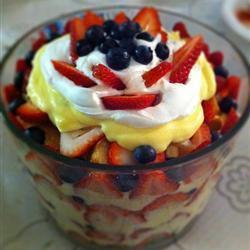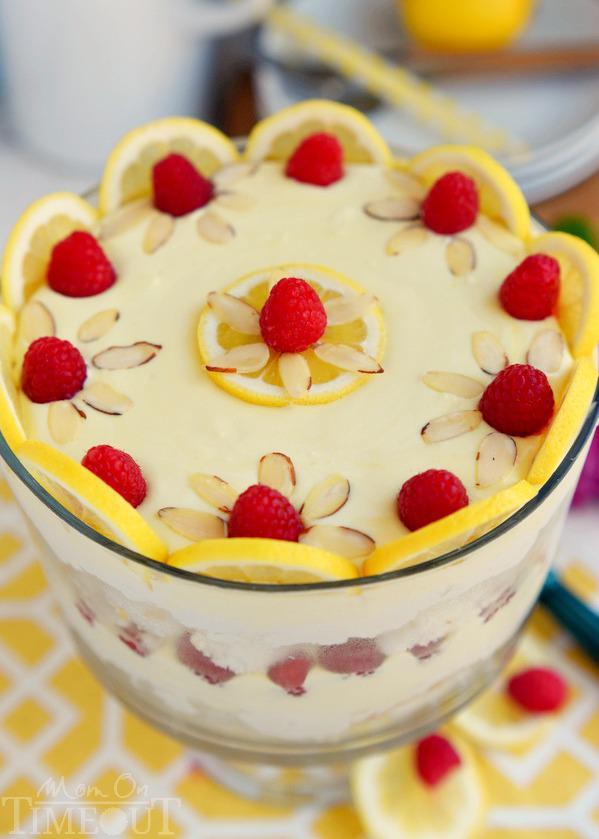The first image is the image on the left, the second image is the image on the right. Assess this claim about the two images: "One of the images contains a lemon in the background on the table.". Correct or not? Answer yes or no. Yes. The first image is the image on the left, the second image is the image on the right. Evaluate the accuracy of this statement regarding the images: "One image shows a layered dessert garnished with blueberries, and all desserts shown in left and right images are garnished with some type of berry.". Is it true? Answer yes or no. Yes. 